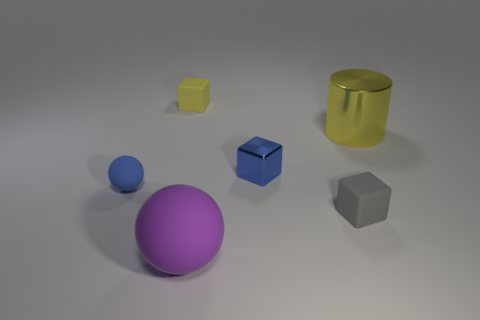Do the large object that is in front of the small gray cube and the shiny thing to the left of the large yellow cylinder have the same shape? No, they do not have the same shape. The large object in front of the small gray cube is a tall yellow cylinder, while the shiny object to the left of the cylinder is a blue sphere. The cylinder has a circular base extended vertically, making its shape cylindrical, whereas the sphere is perfectly round, with every point on its surface equidistant from its center, making its shape spherical. 